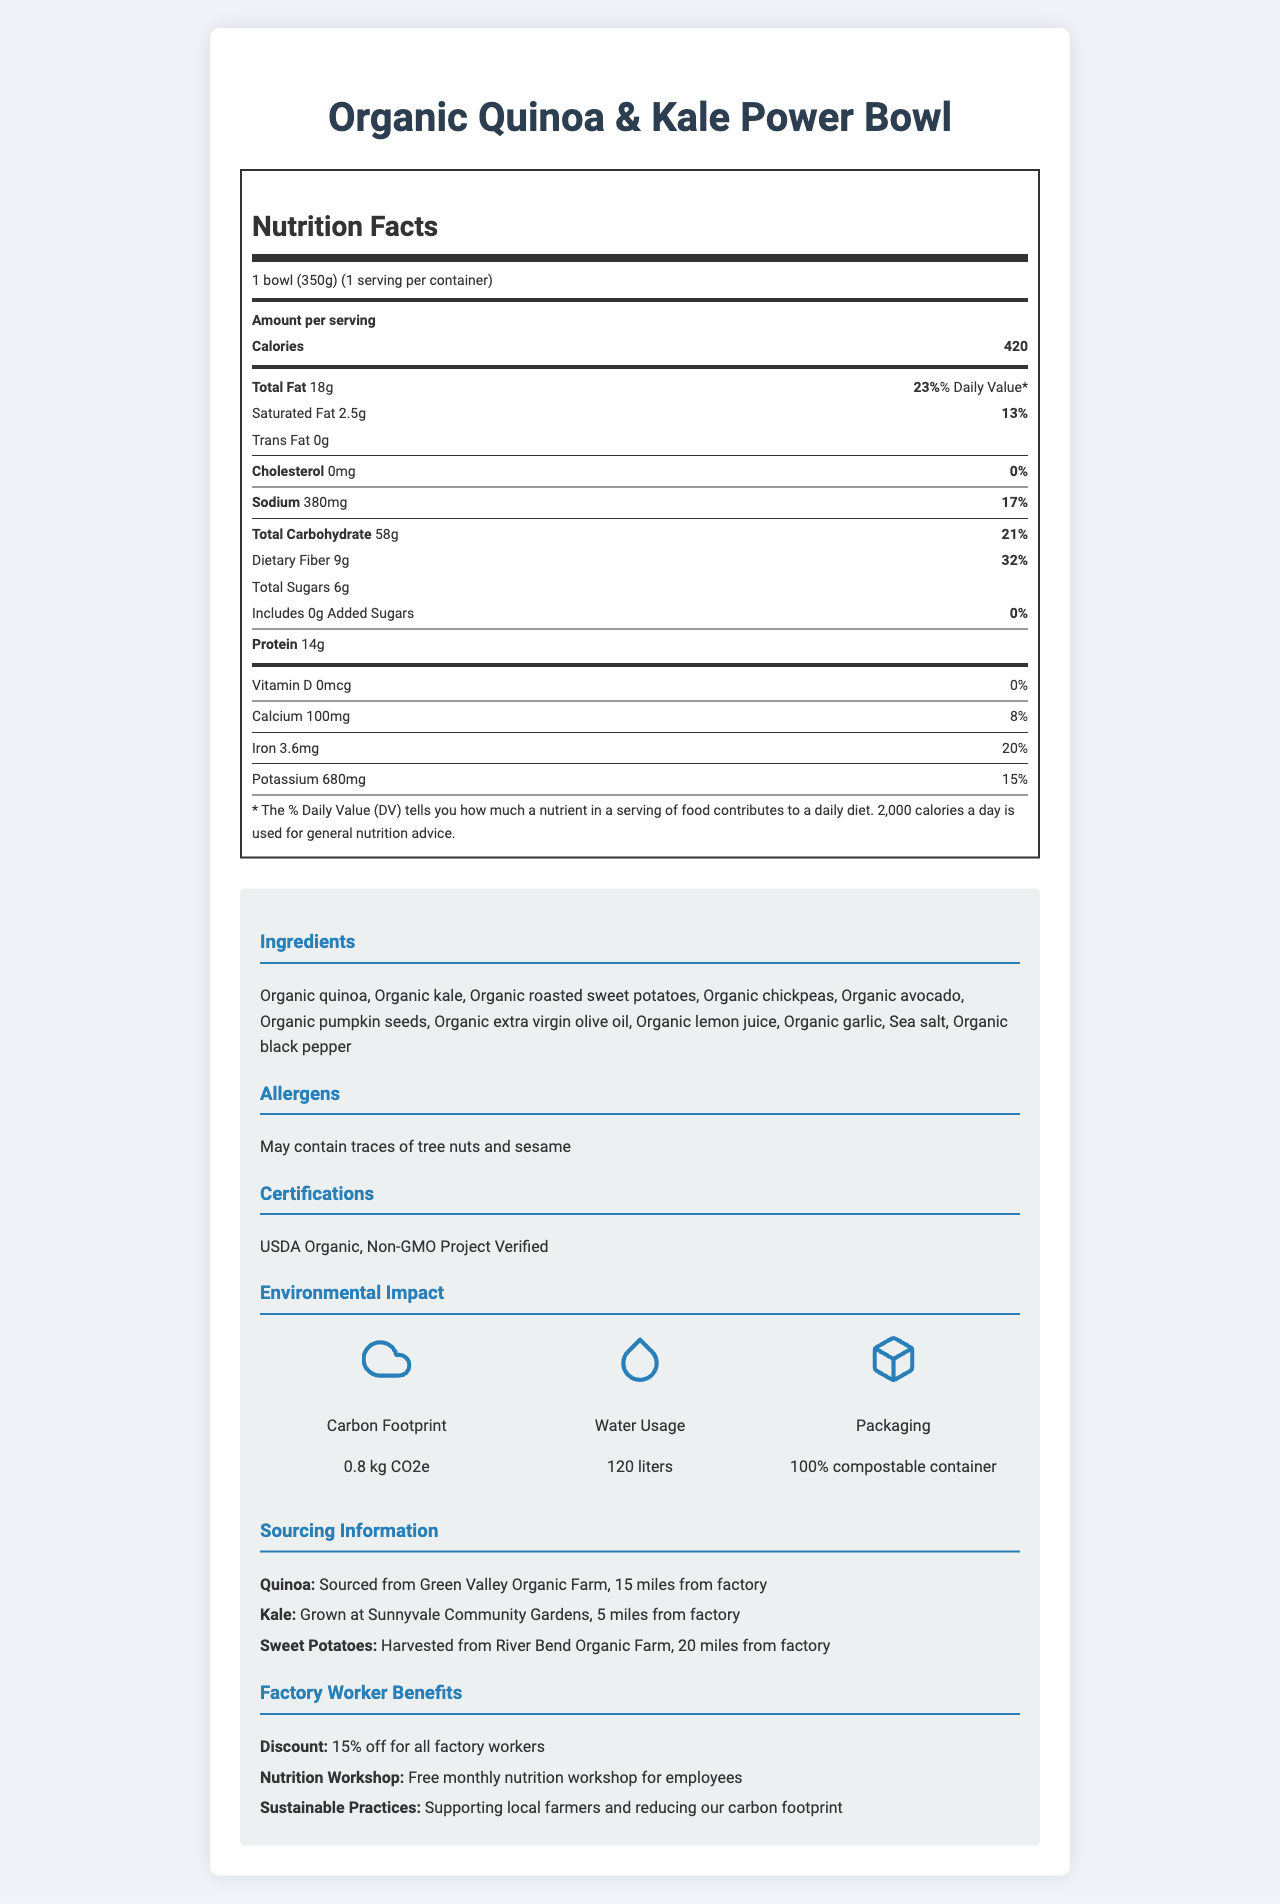What is the serving size of the Organic Quinoa & Kale Power Bowl? The serving size is directly stated under the "Nutrition Facts" heading as "1 bowl (350g)".
Answer: 1 bowl (350g) How many calories are in one serving of the Organic Quinoa & Kale Power Bowl? The calories are stated as "Calories 420" in the "Amount per serving" section.
Answer: 420 What percentage of daily value is the total fat in one serving? The daily value percentage for total fat is listed next to the total fat amount as "23%".
Answer: 23% How much dietary fiber does one serving contain? The amount of dietary fiber is stated as "Dietary Fiber 9g" in the "Total Carbohydrate" section.
Answer: 9g What are the ingredients in the Organic Quinoa & Kale Power Bowl? The ingredients are listed under the "Ingredients" heading in the additional information section.
Answer: Organic quinoa, Organic kale, Organic roasted sweet potatoes, Organic chickpeas, Organic avocado, Organic pumpkin seeds, Organic extra virgin olive oil, Organic lemon juice, Organic garlic, Sea salt, Organic black pepper What is the carbon footprint of this product? A. 2.4 kg CO2e B. 0.8 kg CO2e C. 1.2 kg CO2e The carbon footprint is listed in the "Environmental Impact" section as "Carbon Footprint 0.8 kg CO2e".
Answer: B. 0.8 kg CO2e How many grams of protein does the power bowl contain? A. 12g B. 14g C. 16g The amount of protein is listed directly as "Protein 14g."
Answer: B. 14g Is there any cholesterol in this product? The cholesterol amount is listed as "0mg" with a daily value of "0%" in the "Cholesterol" section.
Answer: No Does the product contain added sugars? The added sugars are listed as "0g" with a daily value of "0%" in the "Total Carbohydrate" section.
Answer: No How much sodium is in one serving? The sodium amount is listed as "Sodium 380mg" with a daily value percentage of "17%".
Answer: 380mg Which farm is the quinoa sourced from? The sourcing information states "Quinoa: Sourced from Green Valley Organic Farm, 15 miles from factory."
Answer: Green Valley Organic Farm What are the benefits offered to factory workers? 1. Free monthly nutrition workshop 2. 20% discount on all meals 3. Support for local farmers A. 1 and 2 B. 1 and 3 C. 2 and 3 The listed benefits in the "Factory Worker Benefits" section are a "15% discount," "Free monthly nutrition workshop," and "Supporting local farmers."
Answer: B. 1 and 3 Summarize the nutritional and environmental benefits of the Organic Quinoa & Kale Power Bowl. The power bowl provides substantial nutrition while maintaining a low environmental impact, utilizing sustainable practices and supporting local farmers. Factory workers receive added perks such as discounts and nutritional education.
Answer: The Organic Quinoa & Kale Power Bowl is a nutritious option with 420 calories per serving, contains 18g of total fat, 14g of protein, and 9g of dietary fiber. It is low in sodium and cholesterol-free. It has a low carbon footprint of 0.8 kg CO2e and utilizes 120 liters of water. It features locally-sourced ingredients and comes in a 100% compostable container. Factory workers benefit from discounts and nutrition workshops. How many calories from fat are in the power bowl? The document does not provide information on how many of the total calories come specifically from fat.
Answer: Cannot be determined What certifications does the Power Bowl have? Under "Certifications," the document lists these two certifications.
Answer: USDA Organic, Non-GMO Project Verified 